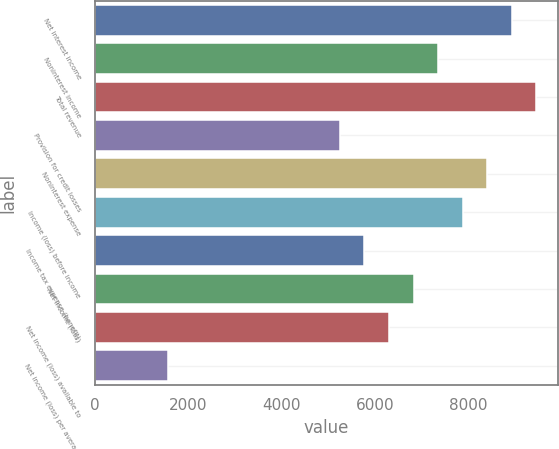<chart> <loc_0><loc_0><loc_500><loc_500><bar_chart><fcel>Net interest income<fcel>Noninterest income<fcel>Total revenue<fcel>Provision for credit losses<fcel>Noninterest expense<fcel>Income (loss) before income<fcel>Income tax expense (benefit)<fcel>Net income (loss)<fcel>Net income (loss) available to<fcel>Net income (loss) per average<nl><fcel>8933.11<fcel>7356.76<fcel>9458.56<fcel>5254.96<fcel>8407.66<fcel>7882.21<fcel>5780.41<fcel>6831.31<fcel>6305.86<fcel>1576.81<nl></chart> 